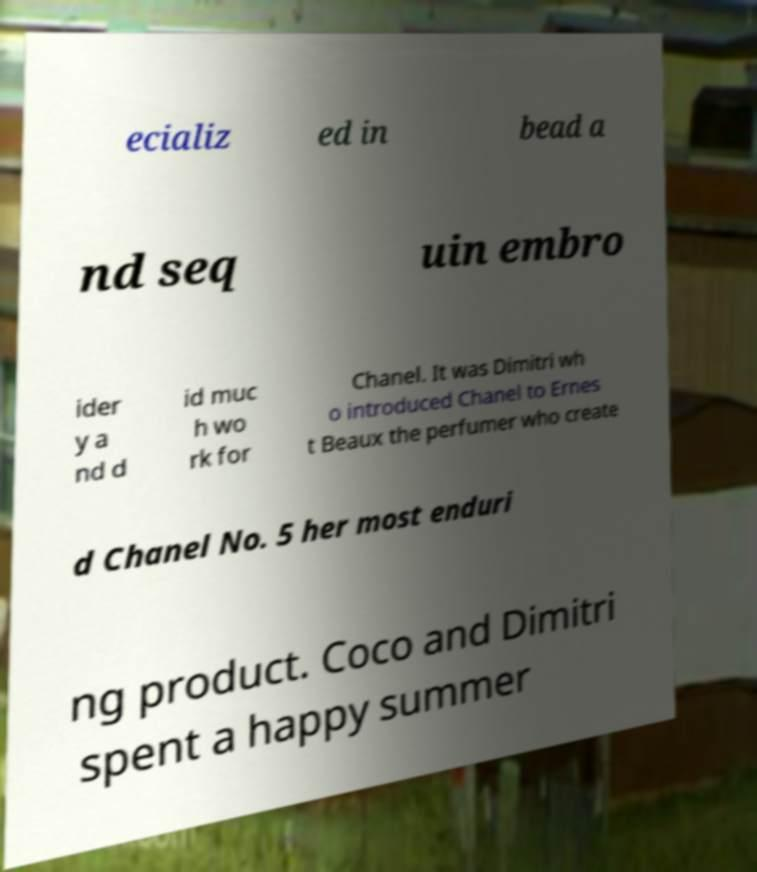What messages or text are displayed in this image? I need them in a readable, typed format. ecializ ed in bead a nd seq uin embro ider y a nd d id muc h wo rk for Chanel. It was Dimitri wh o introduced Chanel to Ernes t Beaux the perfumer who create d Chanel No. 5 her most enduri ng product. Coco and Dimitri spent a happy summer 